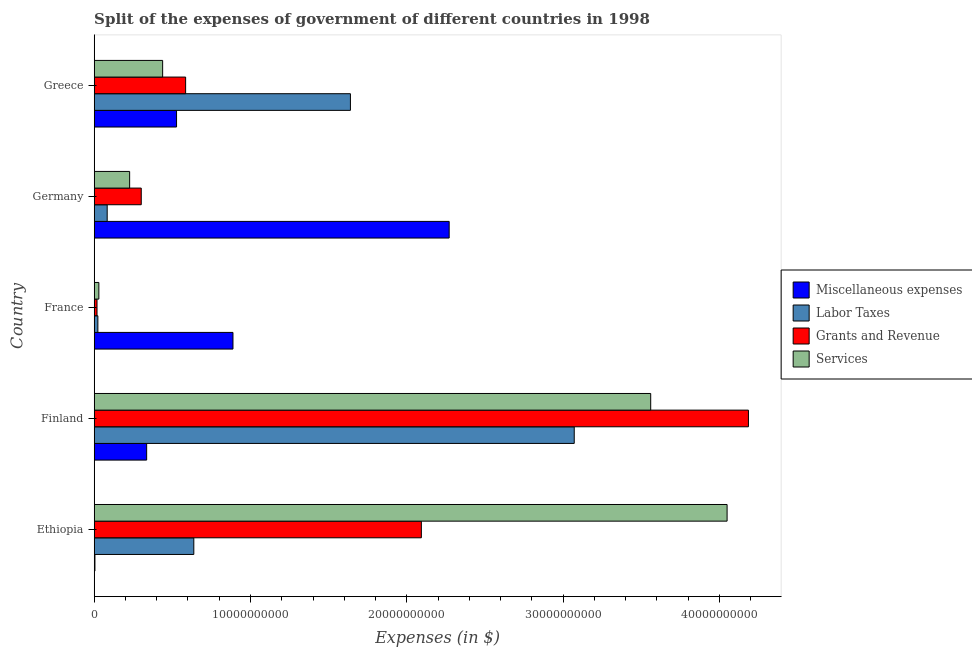How many different coloured bars are there?
Keep it short and to the point. 4. Are the number of bars on each tick of the Y-axis equal?
Keep it short and to the point. Yes. How many bars are there on the 5th tick from the top?
Your answer should be very brief. 4. In how many cases, is the number of bars for a given country not equal to the number of legend labels?
Offer a very short reply. 0. What is the amount spent on labor taxes in France?
Offer a terse response. 2.35e+08. Across all countries, what is the maximum amount spent on miscellaneous expenses?
Keep it short and to the point. 2.27e+1. Across all countries, what is the minimum amount spent on labor taxes?
Provide a short and direct response. 2.35e+08. What is the total amount spent on services in the graph?
Provide a short and direct response. 8.30e+1. What is the difference between the amount spent on labor taxes in Finland and that in France?
Ensure brevity in your answer.  3.05e+1. What is the difference between the amount spent on services in Greece and the amount spent on labor taxes in France?
Provide a short and direct response. 4.14e+09. What is the average amount spent on grants and revenue per country?
Your answer should be compact. 1.44e+1. What is the difference between the amount spent on miscellaneous expenses and amount spent on labor taxes in Ethiopia?
Give a very brief answer. -6.33e+09. In how many countries, is the amount spent on services greater than 6000000000 $?
Keep it short and to the point. 2. What is the ratio of the amount spent on labor taxes in Germany to that in Greece?
Your answer should be very brief. 0.05. Is the amount spent on miscellaneous expenses in Ethiopia less than that in France?
Your response must be concise. Yes. Is the difference between the amount spent on grants and revenue in Ethiopia and Greece greater than the difference between the amount spent on miscellaneous expenses in Ethiopia and Greece?
Make the answer very short. Yes. What is the difference between the highest and the second highest amount spent on miscellaneous expenses?
Your answer should be compact. 1.38e+1. What is the difference between the highest and the lowest amount spent on services?
Your answer should be very brief. 4.02e+1. Is it the case that in every country, the sum of the amount spent on grants and revenue and amount spent on labor taxes is greater than the sum of amount spent on miscellaneous expenses and amount spent on services?
Keep it short and to the point. No. What does the 3rd bar from the top in Germany represents?
Provide a succinct answer. Labor Taxes. What does the 1st bar from the bottom in Germany represents?
Give a very brief answer. Miscellaneous expenses. How many bars are there?
Ensure brevity in your answer.  20. Are all the bars in the graph horizontal?
Your response must be concise. Yes. How many countries are there in the graph?
Give a very brief answer. 5. What is the difference between two consecutive major ticks on the X-axis?
Offer a very short reply. 1.00e+1. Does the graph contain any zero values?
Your response must be concise. No. Does the graph contain grids?
Offer a very short reply. No. Where does the legend appear in the graph?
Ensure brevity in your answer.  Center right. How many legend labels are there?
Ensure brevity in your answer.  4. How are the legend labels stacked?
Your answer should be compact. Vertical. What is the title of the graph?
Offer a terse response. Split of the expenses of government of different countries in 1998. What is the label or title of the X-axis?
Provide a succinct answer. Expenses (in $). What is the label or title of the Y-axis?
Give a very brief answer. Country. What is the Expenses (in $) of Miscellaneous expenses in Ethiopia?
Make the answer very short. 4.77e+07. What is the Expenses (in $) of Labor Taxes in Ethiopia?
Your response must be concise. 6.37e+09. What is the Expenses (in $) in Grants and Revenue in Ethiopia?
Keep it short and to the point. 2.09e+1. What is the Expenses (in $) in Services in Ethiopia?
Make the answer very short. 4.05e+1. What is the Expenses (in $) of Miscellaneous expenses in Finland?
Ensure brevity in your answer.  3.36e+09. What is the Expenses (in $) in Labor Taxes in Finland?
Keep it short and to the point. 3.07e+1. What is the Expenses (in $) of Grants and Revenue in Finland?
Provide a short and direct response. 4.19e+1. What is the Expenses (in $) of Services in Finland?
Give a very brief answer. 3.56e+1. What is the Expenses (in $) of Miscellaneous expenses in France?
Offer a very short reply. 8.88e+09. What is the Expenses (in $) of Labor Taxes in France?
Keep it short and to the point. 2.35e+08. What is the Expenses (in $) of Grants and Revenue in France?
Make the answer very short. 1.80e+08. What is the Expenses (in $) in Services in France?
Your response must be concise. 2.98e+08. What is the Expenses (in $) of Miscellaneous expenses in Germany?
Provide a succinct answer. 2.27e+1. What is the Expenses (in $) in Labor Taxes in Germany?
Ensure brevity in your answer.  8.31e+08. What is the Expenses (in $) of Grants and Revenue in Germany?
Offer a very short reply. 3.01e+09. What is the Expenses (in $) of Services in Germany?
Ensure brevity in your answer.  2.27e+09. What is the Expenses (in $) of Miscellaneous expenses in Greece?
Make the answer very short. 5.27e+09. What is the Expenses (in $) of Labor Taxes in Greece?
Keep it short and to the point. 1.64e+1. What is the Expenses (in $) in Grants and Revenue in Greece?
Provide a short and direct response. 5.85e+09. What is the Expenses (in $) of Services in Greece?
Keep it short and to the point. 4.38e+09. Across all countries, what is the maximum Expenses (in $) of Miscellaneous expenses?
Keep it short and to the point. 2.27e+1. Across all countries, what is the maximum Expenses (in $) in Labor Taxes?
Ensure brevity in your answer.  3.07e+1. Across all countries, what is the maximum Expenses (in $) of Grants and Revenue?
Make the answer very short. 4.19e+1. Across all countries, what is the maximum Expenses (in $) in Services?
Give a very brief answer. 4.05e+1. Across all countries, what is the minimum Expenses (in $) of Miscellaneous expenses?
Your response must be concise. 4.77e+07. Across all countries, what is the minimum Expenses (in $) in Labor Taxes?
Provide a succinct answer. 2.35e+08. Across all countries, what is the minimum Expenses (in $) in Grants and Revenue?
Give a very brief answer. 1.80e+08. Across all countries, what is the minimum Expenses (in $) in Services?
Your response must be concise. 2.98e+08. What is the total Expenses (in $) in Miscellaneous expenses in the graph?
Your response must be concise. 4.03e+1. What is the total Expenses (in $) of Labor Taxes in the graph?
Your response must be concise. 5.45e+1. What is the total Expenses (in $) of Grants and Revenue in the graph?
Give a very brief answer. 7.18e+1. What is the total Expenses (in $) of Services in the graph?
Provide a short and direct response. 8.30e+1. What is the difference between the Expenses (in $) in Miscellaneous expenses in Ethiopia and that in Finland?
Provide a short and direct response. -3.31e+09. What is the difference between the Expenses (in $) in Labor Taxes in Ethiopia and that in Finland?
Ensure brevity in your answer.  -2.43e+1. What is the difference between the Expenses (in $) of Grants and Revenue in Ethiopia and that in Finland?
Your answer should be compact. -2.09e+1. What is the difference between the Expenses (in $) of Services in Ethiopia and that in Finland?
Ensure brevity in your answer.  4.89e+09. What is the difference between the Expenses (in $) of Miscellaneous expenses in Ethiopia and that in France?
Offer a terse response. -8.83e+09. What is the difference between the Expenses (in $) of Labor Taxes in Ethiopia and that in France?
Your response must be concise. 6.14e+09. What is the difference between the Expenses (in $) in Grants and Revenue in Ethiopia and that in France?
Your answer should be very brief. 2.08e+1. What is the difference between the Expenses (in $) of Services in Ethiopia and that in France?
Keep it short and to the point. 4.02e+1. What is the difference between the Expenses (in $) in Miscellaneous expenses in Ethiopia and that in Germany?
Your answer should be very brief. -2.27e+1. What is the difference between the Expenses (in $) of Labor Taxes in Ethiopia and that in Germany?
Provide a short and direct response. 5.54e+09. What is the difference between the Expenses (in $) of Grants and Revenue in Ethiopia and that in Germany?
Provide a succinct answer. 1.79e+1. What is the difference between the Expenses (in $) of Services in Ethiopia and that in Germany?
Your response must be concise. 3.82e+1. What is the difference between the Expenses (in $) of Miscellaneous expenses in Ethiopia and that in Greece?
Offer a terse response. -5.22e+09. What is the difference between the Expenses (in $) in Labor Taxes in Ethiopia and that in Greece?
Provide a short and direct response. -1.00e+1. What is the difference between the Expenses (in $) in Grants and Revenue in Ethiopia and that in Greece?
Keep it short and to the point. 1.51e+1. What is the difference between the Expenses (in $) of Services in Ethiopia and that in Greece?
Your answer should be compact. 3.61e+1. What is the difference between the Expenses (in $) of Miscellaneous expenses in Finland and that in France?
Give a very brief answer. -5.52e+09. What is the difference between the Expenses (in $) of Labor Taxes in Finland and that in France?
Provide a short and direct response. 3.05e+1. What is the difference between the Expenses (in $) in Grants and Revenue in Finland and that in France?
Give a very brief answer. 4.17e+1. What is the difference between the Expenses (in $) of Services in Finland and that in France?
Give a very brief answer. 3.53e+1. What is the difference between the Expenses (in $) of Miscellaneous expenses in Finland and that in Germany?
Ensure brevity in your answer.  -1.94e+1. What is the difference between the Expenses (in $) in Labor Taxes in Finland and that in Germany?
Make the answer very short. 2.99e+1. What is the difference between the Expenses (in $) of Grants and Revenue in Finland and that in Germany?
Provide a succinct answer. 3.88e+1. What is the difference between the Expenses (in $) in Services in Finland and that in Germany?
Offer a terse response. 3.33e+1. What is the difference between the Expenses (in $) of Miscellaneous expenses in Finland and that in Greece?
Your answer should be very brief. -1.91e+09. What is the difference between the Expenses (in $) of Labor Taxes in Finland and that in Greece?
Make the answer very short. 1.43e+1. What is the difference between the Expenses (in $) of Grants and Revenue in Finland and that in Greece?
Your response must be concise. 3.60e+1. What is the difference between the Expenses (in $) of Services in Finland and that in Greece?
Your response must be concise. 3.12e+1. What is the difference between the Expenses (in $) of Miscellaneous expenses in France and that in Germany?
Keep it short and to the point. -1.38e+1. What is the difference between the Expenses (in $) of Labor Taxes in France and that in Germany?
Offer a very short reply. -5.97e+08. What is the difference between the Expenses (in $) of Grants and Revenue in France and that in Germany?
Keep it short and to the point. -2.83e+09. What is the difference between the Expenses (in $) of Services in France and that in Germany?
Make the answer very short. -1.97e+09. What is the difference between the Expenses (in $) in Miscellaneous expenses in France and that in Greece?
Your answer should be very brief. 3.61e+09. What is the difference between the Expenses (in $) of Labor Taxes in France and that in Greece?
Offer a very short reply. -1.62e+1. What is the difference between the Expenses (in $) of Grants and Revenue in France and that in Greece?
Your answer should be compact. -5.67e+09. What is the difference between the Expenses (in $) of Services in France and that in Greece?
Provide a succinct answer. -4.08e+09. What is the difference between the Expenses (in $) of Miscellaneous expenses in Germany and that in Greece?
Keep it short and to the point. 1.74e+1. What is the difference between the Expenses (in $) of Labor Taxes in Germany and that in Greece?
Your answer should be compact. -1.56e+1. What is the difference between the Expenses (in $) of Grants and Revenue in Germany and that in Greece?
Offer a terse response. -2.84e+09. What is the difference between the Expenses (in $) in Services in Germany and that in Greece?
Give a very brief answer. -2.11e+09. What is the difference between the Expenses (in $) in Miscellaneous expenses in Ethiopia and the Expenses (in $) in Labor Taxes in Finland?
Offer a terse response. -3.07e+1. What is the difference between the Expenses (in $) in Miscellaneous expenses in Ethiopia and the Expenses (in $) in Grants and Revenue in Finland?
Provide a short and direct response. -4.18e+1. What is the difference between the Expenses (in $) in Miscellaneous expenses in Ethiopia and the Expenses (in $) in Services in Finland?
Give a very brief answer. -3.56e+1. What is the difference between the Expenses (in $) in Labor Taxes in Ethiopia and the Expenses (in $) in Grants and Revenue in Finland?
Offer a terse response. -3.55e+1. What is the difference between the Expenses (in $) in Labor Taxes in Ethiopia and the Expenses (in $) in Services in Finland?
Provide a succinct answer. -2.92e+1. What is the difference between the Expenses (in $) of Grants and Revenue in Ethiopia and the Expenses (in $) of Services in Finland?
Offer a terse response. -1.47e+1. What is the difference between the Expenses (in $) in Miscellaneous expenses in Ethiopia and the Expenses (in $) in Labor Taxes in France?
Provide a succinct answer. -1.87e+08. What is the difference between the Expenses (in $) in Miscellaneous expenses in Ethiopia and the Expenses (in $) in Grants and Revenue in France?
Your response must be concise. -1.32e+08. What is the difference between the Expenses (in $) in Miscellaneous expenses in Ethiopia and the Expenses (in $) in Services in France?
Offer a very short reply. -2.50e+08. What is the difference between the Expenses (in $) of Labor Taxes in Ethiopia and the Expenses (in $) of Grants and Revenue in France?
Your answer should be compact. 6.19e+09. What is the difference between the Expenses (in $) in Labor Taxes in Ethiopia and the Expenses (in $) in Services in France?
Make the answer very short. 6.08e+09. What is the difference between the Expenses (in $) of Grants and Revenue in Ethiopia and the Expenses (in $) of Services in France?
Provide a short and direct response. 2.06e+1. What is the difference between the Expenses (in $) of Miscellaneous expenses in Ethiopia and the Expenses (in $) of Labor Taxes in Germany?
Give a very brief answer. -7.84e+08. What is the difference between the Expenses (in $) of Miscellaneous expenses in Ethiopia and the Expenses (in $) of Grants and Revenue in Germany?
Your answer should be compact. -2.96e+09. What is the difference between the Expenses (in $) of Miscellaneous expenses in Ethiopia and the Expenses (in $) of Services in Germany?
Offer a very short reply. -2.22e+09. What is the difference between the Expenses (in $) of Labor Taxes in Ethiopia and the Expenses (in $) of Grants and Revenue in Germany?
Give a very brief answer. 3.36e+09. What is the difference between the Expenses (in $) in Labor Taxes in Ethiopia and the Expenses (in $) in Services in Germany?
Offer a very short reply. 4.11e+09. What is the difference between the Expenses (in $) of Grants and Revenue in Ethiopia and the Expenses (in $) of Services in Germany?
Keep it short and to the point. 1.87e+1. What is the difference between the Expenses (in $) in Miscellaneous expenses in Ethiopia and the Expenses (in $) in Labor Taxes in Greece?
Offer a terse response. -1.63e+1. What is the difference between the Expenses (in $) of Miscellaneous expenses in Ethiopia and the Expenses (in $) of Grants and Revenue in Greece?
Give a very brief answer. -5.80e+09. What is the difference between the Expenses (in $) of Miscellaneous expenses in Ethiopia and the Expenses (in $) of Services in Greece?
Ensure brevity in your answer.  -4.33e+09. What is the difference between the Expenses (in $) of Labor Taxes in Ethiopia and the Expenses (in $) of Grants and Revenue in Greece?
Provide a short and direct response. 5.24e+08. What is the difference between the Expenses (in $) in Labor Taxes in Ethiopia and the Expenses (in $) in Services in Greece?
Provide a short and direct response. 1.99e+09. What is the difference between the Expenses (in $) in Grants and Revenue in Ethiopia and the Expenses (in $) in Services in Greece?
Provide a short and direct response. 1.66e+1. What is the difference between the Expenses (in $) of Miscellaneous expenses in Finland and the Expenses (in $) of Labor Taxes in France?
Ensure brevity in your answer.  3.12e+09. What is the difference between the Expenses (in $) of Miscellaneous expenses in Finland and the Expenses (in $) of Grants and Revenue in France?
Offer a very short reply. 3.18e+09. What is the difference between the Expenses (in $) in Miscellaneous expenses in Finland and the Expenses (in $) in Services in France?
Give a very brief answer. 3.06e+09. What is the difference between the Expenses (in $) of Labor Taxes in Finland and the Expenses (in $) of Grants and Revenue in France?
Provide a short and direct response. 3.05e+1. What is the difference between the Expenses (in $) of Labor Taxes in Finland and the Expenses (in $) of Services in France?
Provide a short and direct response. 3.04e+1. What is the difference between the Expenses (in $) of Grants and Revenue in Finland and the Expenses (in $) of Services in France?
Offer a very short reply. 4.16e+1. What is the difference between the Expenses (in $) of Miscellaneous expenses in Finland and the Expenses (in $) of Labor Taxes in Germany?
Give a very brief answer. 2.52e+09. What is the difference between the Expenses (in $) in Miscellaneous expenses in Finland and the Expenses (in $) in Grants and Revenue in Germany?
Keep it short and to the point. 3.46e+08. What is the difference between the Expenses (in $) of Miscellaneous expenses in Finland and the Expenses (in $) of Services in Germany?
Keep it short and to the point. 1.09e+09. What is the difference between the Expenses (in $) in Labor Taxes in Finland and the Expenses (in $) in Grants and Revenue in Germany?
Your response must be concise. 2.77e+1. What is the difference between the Expenses (in $) of Labor Taxes in Finland and the Expenses (in $) of Services in Germany?
Give a very brief answer. 2.84e+1. What is the difference between the Expenses (in $) in Grants and Revenue in Finland and the Expenses (in $) in Services in Germany?
Provide a succinct answer. 3.96e+1. What is the difference between the Expenses (in $) of Miscellaneous expenses in Finland and the Expenses (in $) of Labor Taxes in Greece?
Your response must be concise. -1.30e+1. What is the difference between the Expenses (in $) in Miscellaneous expenses in Finland and the Expenses (in $) in Grants and Revenue in Greece?
Give a very brief answer. -2.49e+09. What is the difference between the Expenses (in $) of Miscellaneous expenses in Finland and the Expenses (in $) of Services in Greece?
Offer a very short reply. -1.02e+09. What is the difference between the Expenses (in $) of Labor Taxes in Finland and the Expenses (in $) of Grants and Revenue in Greece?
Provide a short and direct response. 2.49e+1. What is the difference between the Expenses (in $) of Labor Taxes in Finland and the Expenses (in $) of Services in Greece?
Keep it short and to the point. 2.63e+1. What is the difference between the Expenses (in $) of Grants and Revenue in Finland and the Expenses (in $) of Services in Greece?
Ensure brevity in your answer.  3.75e+1. What is the difference between the Expenses (in $) in Miscellaneous expenses in France and the Expenses (in $) in Labor Taxes in Germany?
Keep it short and to the point. 8.05e+09. What is the difference between the Expenses (in $) of Miscellaneous expenses in France and the Expenses (in $) of Grants and Revenue in Germany?
Give a very brief answer. 5.87e+09. What is the difference between the Expenses (in $) of Miscellaneous expenses in France and the Expenses (in $) of Services in Germany?
Offer a very short reply. 6.61e+09. What is the difference between the Expenses (in $) in Labor Taxes in France and the Expenses (in $) in Grants and Revenue in Germany?
Your response must be concise. -2.78e+09. What is the difference between the Expenses (in $) in Labor Taxes in France and the Expenses (in $) in Services in Germany?
Your answer should be compact. -2.03e+09. What is the difference between the Expenses (in $) in Grants and Revenue in France and the Expenses (in $) in Services in Germany?
Provide a succinct answer. -2.09e+09. What is the difference between the Expenses (in $) of Miscellaneous expenses in France and the Expenses (in $) of Labor Taxes in Greece?
Your answer should be very brief. -7.51e+09. What is the difference between the Expenses (in $) in Miscellaneous expenses in France and the Expenses (in $) in Grants and Revenue in Greece?
Ensure brevity in your answer.  3.03e+09. What is the difference between the Expenses (in $) of Miscellaneous expenses in France and the Expenses (in $) of Services in Greece?
Your answer should be compact. 4.50e+09. What is the difference between the Expenses (in $) of Labor Taxes in France and the Expenses (in $) of Grants and Revenue in Greece?
Make the answer very short. -5.61e+09. What is the difference between the Expenses (in $) in Labor Taxes in France and the Expenses (in $) in Services in Greece?
Keep it short and to the point. -4.14e+09. What is the difference between the Expenses (in $) of Grants and Revenue in France and the Expenses (in $) of Services in Greece?
Provide a short and direct response. -4.20e+09. What is the difference between the Expenses (in $) of Miscellaneous expenses in Germany and the Expenses (in $) of Labor Taxes in Greece?
Give a very brief answer. 6.32e+09. What is the difference between the Expenses (in $) in Miscellaneous expenses in Germany and the Expenses (in $) in Grants and Revenue in Greece?
Give a very brief answer. 1.69e+1. What is the difference between the Expenses (in $) in Miscellaneous expenses in Germany and the Expenses (in $) in Services in Greece?
Offer a terse response. 1.83e+1. What is the difference between the Expenses (in $) in Labor Taxes in Germany and the Expenses (in $) in Grants and Revenue in Greece?
Ensure brevity in your answer.  -5.02e+09. What is the difference between the Expenses (in $) in Labor Taxes in Germany and the Expenses (in $) in Services in Greece?
Your answer should be compact. -3.55e+09. What is the difference between the Expenses (in $) of Grants and Revenue in Germany and the Expenses (in $) of Services in Greece?
Your answer should be very brief. -1.37e+09. What is the average Expenses (in $) in Miscellaneous expenses per country?
Your answer should be compact. 8.05e+09. What is the average Expenses (in $) of Labor Taxes per country?
Keep it short and to the point. 1.09e+1. What is the average Expenses (in $) in Grants and Revenue per country?
Ensure brevity in your answer.  1.44e+1. What is the average Expenses (in $) in Services per country?
Offer a terse response. 1.66e+1. What is the difference between the Expenses (in $) of Miscellaneous expenses and Expenses (in $) of Labor Taxes in Ethiopia?
Give a very brief answer. -6.33e+09. What is the difference between the Expenses (in $) in Miscellaneous expenses and Expenses (in $) in Grants and Revenue in Ethiopia?
Keep it short and to the point. -2.09e+1. What is the difference between the Expenses (in $) of Miscellaneous expenses and Expenses (in $) of Services in Ethiopia?
Keep it short and to the point. -4.04e+1. What is the difference between the Expenses (in $) of Labor Taxes and Expenses (in $) of Grants and Revenue in Ethiopia?
Your answer should be compact. -1.46e+1. What is the difference between the Expenses (in $) of Labor Taxes and Expenses (in $) of Services in Ethiopia?
Your answer should be very brief. -3.41e+1. What is the difference between the Expenses (in $) in Grants and Revenue and Expenses (in $) in Services in Ethiopia?
Provide a succinct answer. -1.96e+1. What is the difference between the Expenses (in $) in Miscellaneous expenses and Expenses (in $) in Labor Taxes in Finland?
Your answer should be compact. -2.74e+1. What is the difference between the Expenses (in $) of Miscellaneous expenses and Expenses (in $) of Grants and Revenue in Finland?
Provide a short and direct response. -3.85e+1. What is the difference between the Expenses (in $) in Miscellaneous expenses and Expenses (in $) in Services in Finland?
Make the answer very short. -3.22e+1. What is the difference between the Expenses (in $) of Labor Taxes and Expenses (in $) of Grants and Revenue in Finland?
Make the answer very short. -1.11e+1. What is the difference between the Expenses (in $) in Labor Taxes and Expenses (in $) in Services in Finland?
Offer a terse response. -4.89e+09. What is the difference between the Expenses (in $) in Grants and Revenue and Expenses (in $) in Services in Finland?
Your response must be concise. 6.25e+09. What is the difference between the Expenses (in $) of Miscellaneous expenses and Expenses (in $) of Labor Taxes in France?
Your response must be concise. 8.64e+09. What is the difference between the Expenses (in $) in Miscellaneous expenses and Expenses (in $) in Grants and Revenue in France?
Ensure brevity in your answer.  8.70e+09. What is the difference between the Expenses (in $) in Miscellaneous expenses and Expenses (in $) in Services in France?
Provide a succinct answer. 8.58e+09. What is the difference between the Expenses (in $) of Labor Taxes and Expenses (in $) of Grants and Revenue in France?
Provide a succinct answer. 5.47e+07. What is the difference between the Expenses (in $) of Labor Taxes and Expenses (in $) of Services in France?
Your answer should be very brief. -6.32e+07. What is the difference between the Expenses (in $) in Grants and Revenue and Expenses (in $) in Services in France?
Your answer should be very brief. -1.18e+08. What is the difference between the Expenses (in $) in Miscellaneous expenses and Expenses (in $) in Labor Taxes in Germany?
Offer a terse response. 2.19e+1. What is the difference between the Expenses (in $) in Miscellaneous expenses and Expenses (in $) in Grants and Revenue in Germany?
Offer a terse response. 1.97e+1. What is the difference between the Expenses (in $) of Miscellaneous expenses and Expenses (in $) of Services in Germany?
Provide a short and direct response. 2.04e+1. What is the difference between the Expenses (in $) in Labor Taxes and Expenses (in $) in Grants and Revenue in Germany?
Make the answer very short. -2.18e+09. What is the difference between the Expenses (in $) in Labor Taxes and Expenses (in $) in Services in Germany?
Your answer should be very brief. -1.44e+09. What is the difference between the Expenses (in $) in Grants and Revenue and Expenses (in $) in Services in Germany?
Offer a terse response. 7.42e+08. What is the difference between the Expenses (in $) of Miscellaneous expenses and Expenses (in $) of Labor Taxes in Greece?
Your answer should be very brief. -1.11e+1. What is the difference between the Expenses (in $) in Miscellaneous expenses and Expenses (in $) in Grants and Revenue in Greece?
Provide a succinct answer. -5.81e+08. What is the difference between the Expenses (in $) of Miscellaneous expenses and Expenses (in $) of Services in Greece?
Your answer should be very brief. 8.89e+08. What is the difference between the Expenses (in $) of Labor Taxes and Expenses (in $) of Grants and Revenue in Greece?
Provide a succinct answer. 1.05e+1. What is the difference between the Expenses (in $) in Labor Taxes and Expenses (in $) in Services in Greece?
Offer a very short reply. 1.20e+1. What is the difference between the Expenses (in $) of Grants and Revenue and Expenses (in $) of Services in Greece?
Offer a very short reply. 1.47e+09. What is the ratio of the Expenses (in $) of Miscellaneous expenses in Ethiopia to that in Finland?
Offer a terse response. 0.01. What is the ratio of the Expenses (in $) in Labor Taxes in Ethiopia to that in Finland?
Your answer should be compact. 0.21. What is the ratio of the Expenses (in $) in Grants and Revenue in Ethiopia to that in Finland?
Your response must be concise. 0.5. What is the ratio of the Expenses (in $) in Services in Ethiopia to that in Finland?
Provide a short and direct response. 1.14. What is the ratio of the Expenses (in $) in Miscellaneous expenses in Ethiopia to that in France?
Your answer should be very brief. 0.01. What is the ratio of the Expenses (in $) in Labor Taxes in Ethiopia to that in France?
Give a very brief answer. 27.14. What is the ratio of the Expenses (in $) in Grants and Revenue in Ethiopia to that in France?
Your answer should be compact. 116.22. What is the ratio of the Expenses (in $) of Services in Ethiopia to that in France?
Your response must be concise. 135.88. What is the ratio of the Expenses (in $) in Miscellaneous expenses in Ethiopia to that in Germany?
Your answer should be very brief. 0. What is the ratio of the Expenses (in $) of Labor Taxes in Ethiopia to that in Germany?
Offer a terse response. 7.67. What is the ratio of the Expenses (in $) of Grants and Revenue in Ethiopia to that in Germany?
Give a very brief answer. 6.95. What is the ratio of the Expenses (in $) in Services in Ethiopia to that in Germany?
Give a very brief answer. 17.86. What is the ratio of the Expenses (in $) in Miscellaneous expenses in Ethiopia to that in Greece?
Your answer should be very brief. 0.01. What is the ratio of the Expenses (in $) in Labor Taxes in Ethiopia to that in Greece?
Make the answer very short. 0.39. What is the ratio of the Expenses (in $) in Grants and Revenue in Ethiopia to that in Greece?
Give a very brief answer. 3.58. What is the ratio of the Expenses (in $) of Services in Ethiopia to that in Greece?
Make the answer very short. 9.25. What is the ratio of the Expenses (in $) of Miscellaneous expenses in Finland to that in France?
Your answer should be compact. 0.38. What is the ratio of the Expenses (in $) of Labor Taxes in Finland to that in France?
Offer a very short reply. 130.8. What is the ratio of the Expenses (in $) of Grants and Revenue in Finland to that in France?
Ensure brevity in your answer.  232.4. What is the ratio of the Expenses (in $) in Services in Finland to that in France?
Offer a very short reply. 119.47. What is the ratio of the Expenses (in $) in Miscellaneous expenses in Finland to that in Germany?
Provide a short and direct response. 0.15. What is the ratio of the Expenses (in $) in Labor Taxes in Finland to that in Germany?
Offer a very short reply. 36.94. What is the ratio of the Expenses (in $) in Grants and Revenue in Finland to that in Germany?
Keep it short and to the point. 13.91. What is the ratio of the Expenses (in $) in Services in Finland to that in Germany?
Provide a succinct answer. 15.7. What is the ratio of the Expenses (in $) of Miscellaneous expenses in Finland to that in Greece?
Offer a terse response. 0.64. What is the ratio of the Expenses (in $) of Labor Taxes in Finland to that in Greece?
Keep it short and to the point. 1.87. What is the ratio of the Expenses (in $) in Grants and Revenue in Finland to that in Greece?
Your response must be concise. 7.16. What is the ratio of the Expenses (in $) in Services in Finland to that in Greece?
Offer a very short reply. 8.13. What is the ratio of the Expenses (in $) in Miscellaneous expenses in France to that in Germany?
Make the answer very short. 0.39. What is the ratio of the Expenses (in $) in Labor Taxes in France to that in Germany?
Give a very brief answer. 0.28. What is the ratio of the Expenses (in $) of Grants and Revenue in France to that in Germany?
Provide a succinct answer. 0.06. What is the ratio of the Expenses (in $) in Services in France to that in Germany?
Provide a succinct answer. 0.13. What is the ratio of the Expenses (in $) of Miscellaneous expenses in France to that in Greece?
Offer a very short reply. 1.69. What is the ratio of the Expenses (in $) in Labor Taxes in France to that in Greece?
Your answer should be compact. 0.01. What is the ratio of the Expenses (in $) of Grants and Revenue in France to that in Greece?
Provide a short and direct response. 0.03. What is the ratio of the Expenses (in $) of Services in France to that in Greece?
Ensure brevity in your answer.  0.07. What is the ratio of the Expenses (in $) in Miscellaneous expenses in Germany to that in Greece?
Your response must be concise. 4.31. What is the ratio of the Expenses (in $) of Labor Taxes in Germany to that in Greece?
Ensure brevity in your answer.  0.05. What is the ratio of the Expenses (in $) of Grants and Revenue in Germany to that in Greece?
Provide a succinct answer. 0.51. What is the ratio of the Expenses (in $) in Services in Germany to that in Greece?
Make the answer very short. 0.52. What is the difference between the highest and the second highest Expenses (in $) in Miscellaneous expenses?
Give a very brief answer. 1.38e+1. What is the difference between the highest and the second highest Expenses (in $) in Labor Taxes?
Offer a very short reply. 1.43e+1. What is the difference between the highest and the second highest Expenses (in $) of Grants and Revenue?
Offer a terse response. 2.09e+1. What is the difference between the highest and the second highest Expenses (in $) in Services?
Your answer should be compact. 4.89e+09. What is the difference between the highest and the lowest Expenses (in $) of Miscellaneous expenses?
Provide a succinct answer. 2.27e+1. What is the difference between the highest and the lowest Expenses (in $) in Labor Taxes?
Give a very brief answer. 3.05e+1. What is the difference between the highest and the lowest Expenses (in $) of Grants and Revenue?
Your answer should be very brief. 4.17e+1. What is the difference between the highest and the lowest Expenses (in $) in Services?
Give a very brief answer. 4.02e+1. 